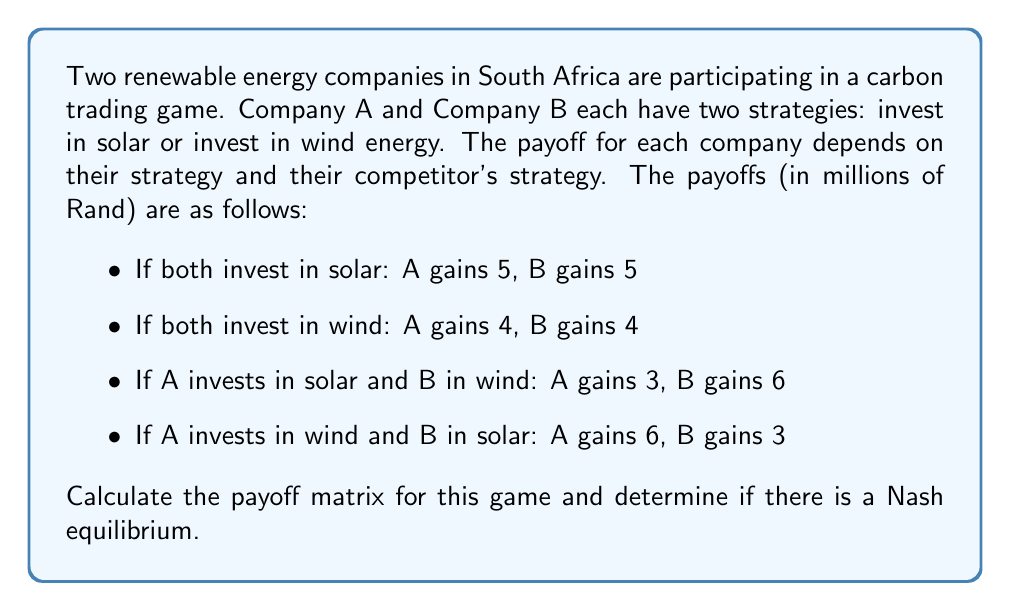Give your solution to this math problem. To solve this problem, we need to follow these steps:

1. Construct the payoff matrix
2. Identify the best responses for each player
3. Determine if there is a Nash equilibrium

Step 1: Constructing the payoff matrix

The payoff matrix is a 2x2 matrix where each cell contains a pair of payoffs (A's payoff, B's payoff) for each combination of strategies:

$$
\begin{array}{c|c|c}
 & \text{B: Solar} & \text{B: Wind} \\
\hline
\text{A: Solar} & (5,5) & (3,6) \\
\hline
\text{A: Wind} & (6,3) & (4,4)
\end{array}
$$

Step 2: Identifying best responses

For each of Player A's strategies, we underline Player A's best response to each of Player B's strategies:

$$
\begin{array}{c|c|c}
 & \text{B: Solar} & \text{B: Wind} \\
\hline
\text{A: Solar} & (5,5) & (3,6) \\
\hline
\text{A: Wind} & \underline{(6,3)} & \underline{(4,4)}
\end{array}
$$

For each of Player B's strategies, we underline Player B's best response to each of Player A's strategies:

$$
\begin{array}{c|c|c}
 & \text{B: Solar} & \text{B: Wind} \\
\hline
\text{A: Solar} & (5,\underline{5}) & (3,\underline{6}) \\
\hline
\text{A: Wind} & (\underline{6},3) & (4,4)
\end{array}
$$

Step 3: Determining Nash equilibrium

A Nash equilibrium occurs when both players are playing their best responses to each other's strategies. This happens when there is a cell in the matrix where both payoffs are underlined.

In this case, we can see that there is no cell where both payoffs are underlined, which means there is no pure strategy Nash equilibrium for this game.
Answer: The payoff matrix for the game is:

$$
\begin{array}{c|c|c}
 & \text{B: Solar} & \text{B: Wind} \\
\hline
\text{A: Solar} & (5,5) & (3,6) \\
\hline
\text{A: Wind} & (6,3) & (4,4)
\end{array}
$$

There is no pure strategy Nash equilibrium in this game. 